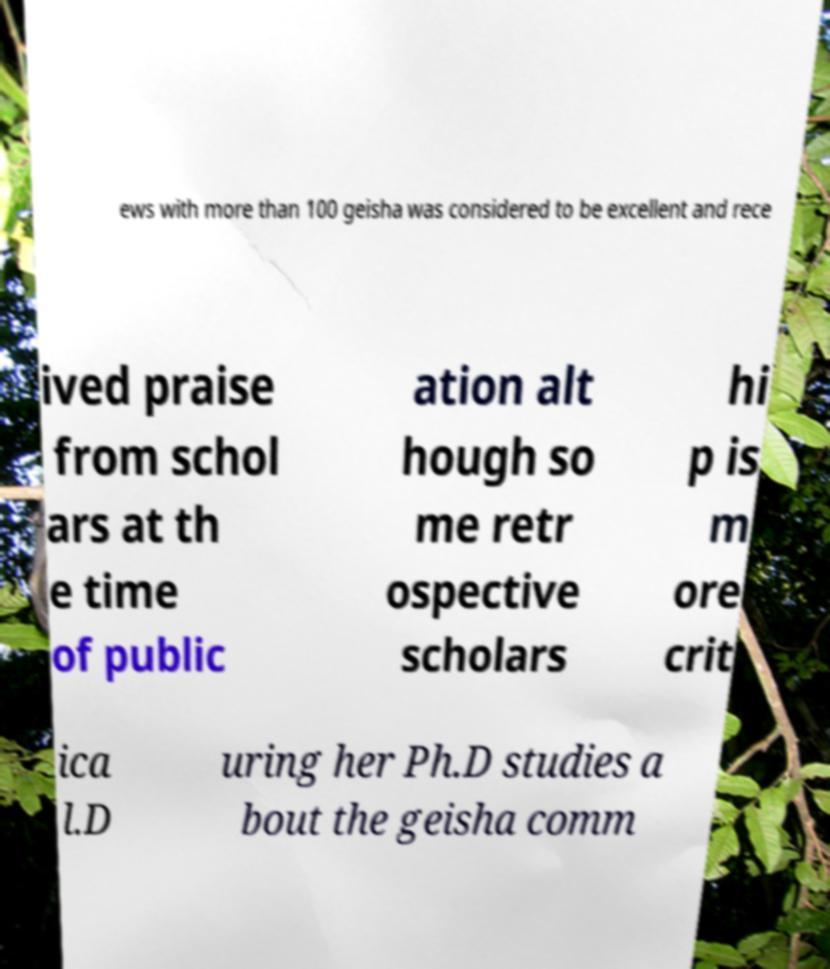I need the written content from this picture converted into text. Can you do that? ews with more than 100 geisha was considered to be excellent and rece ived praise from schol ars at th e time of public ation alt hough so me retr ospective scholars hi p is m ore crit ica l.D uring her Ph.D studies a bout the geisha comm 